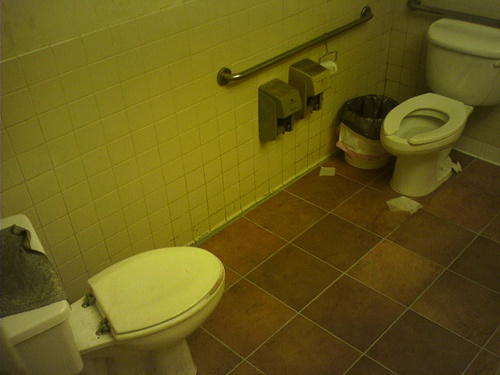Describe the objects in this image and their specific colors. I can see toilet in gray, olive, and black tones and toilet in gray, olive, black, and darkgreen tones in this image. 